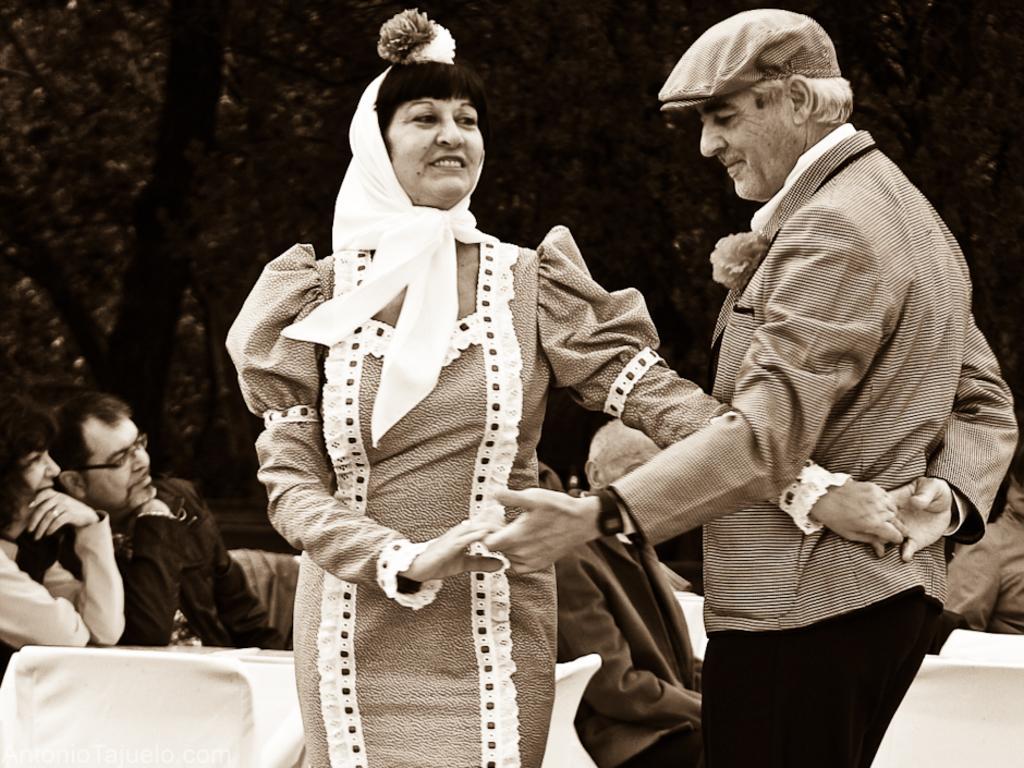How would you summarize this image in a sentence or two? In this image there are two people in the foreground. There are chairs, tables, trees and people in the background. 